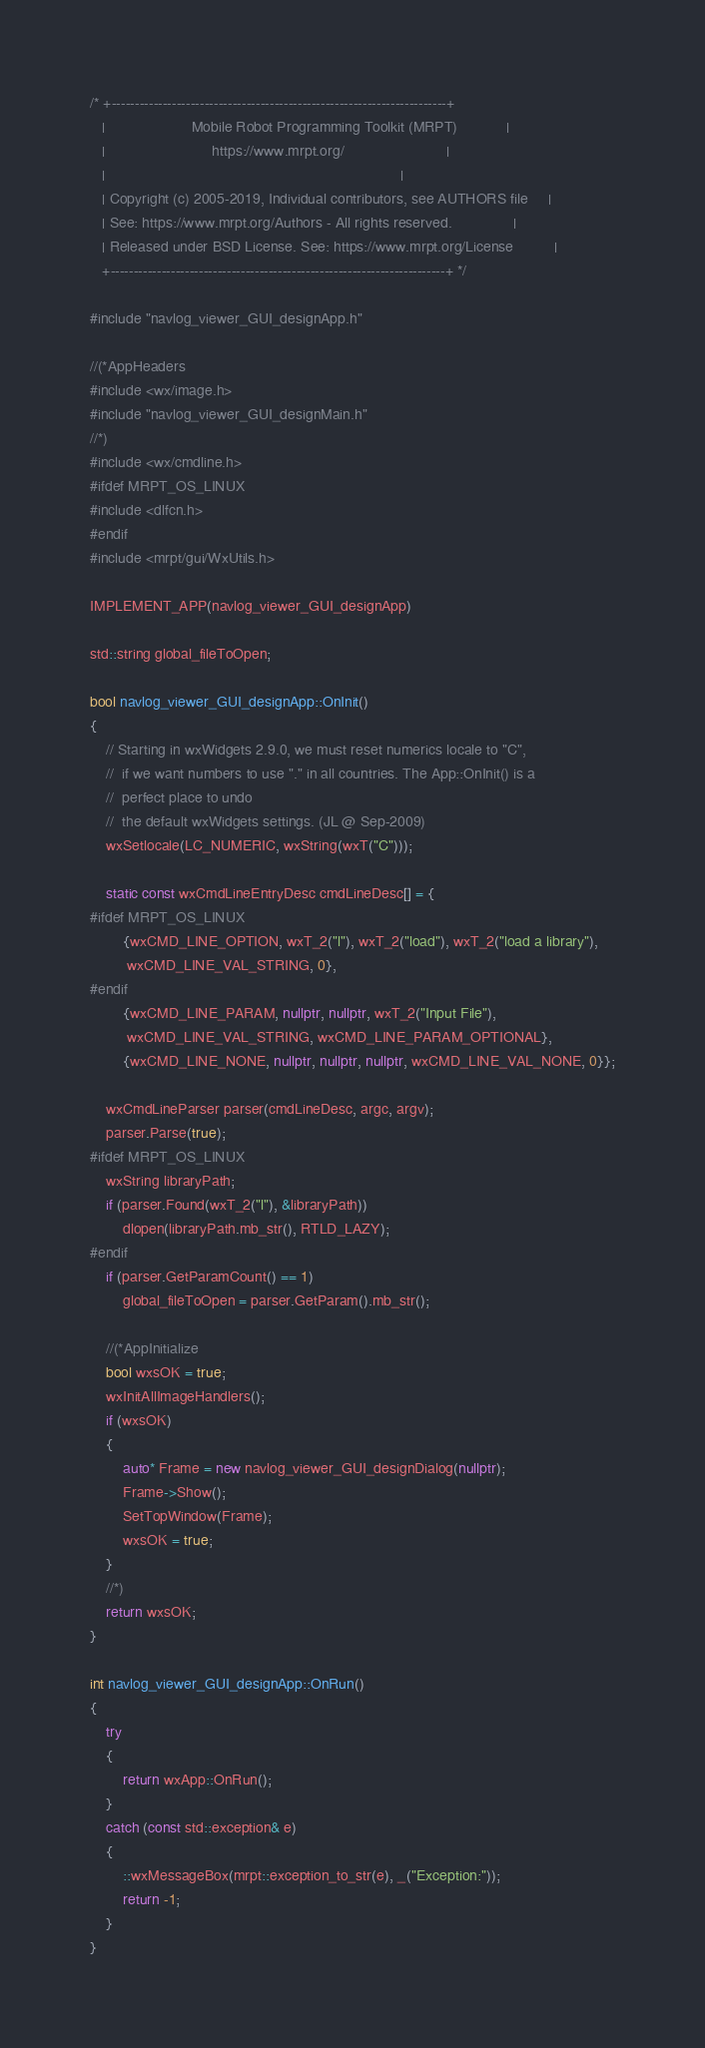<code> <loc_0><loc_0><loc_500><loc_500><_C++_>/* +------------------------------------------------------------------------+
   |                     Mobile Robot Programming Toolkit (MRPT)            |
   |                          https://www.mrpt.org/                         |
   |                                                                        |
   | Copyright (c) 2005-2019, Individual contributors, see AUTHORS file     |
   | See: https://www.mrpt.org/Authors - All rights reserved.               |
   | Released under BSD License. See: https://www.mrpt.org/License          |
   +------------------------------------------------------------------------+ */

#include "navlog_viewer_GUI_designApp.h"

//(*AppHeaders
#include <wx/image.h>
#include "navlog_viewer_GUI_designMain.h"
//*)
#include <wx/cmdline.h>
#ifdef MRPT_OS_LINUX
#include <dlfcn.h>
#endif
#include <mrpt/gui/WxUtils.h>

IMPLEMENT_APP(navlog_viewer_GUI_designApp)

std::string global_fileToOpen;

bool navlog_viewer_GUI_designApp::OnInit()
{
	// Starting in wxWidgets 2.9.0, we must reset numerics locale to "C",
	//  if we want numbers to use "." in all countries. The App::OnInit() is a
	//  perfect place to undo
	//  the default wxWidgets settings. (JL @ Sep-2009)
	wxSetlocale(LC_NUMERIC, wxString(wxT("C")));

	static const wxCmdLineEntryDesc cmdLineDesc[] = {
#ifdef MRPT_OS_LINUX
		{wxCMD_LINE_OPTION, wxT_2("l"), wxT_2("load"), wxT_2("load a library"),
		 wxCMD_LINE_VAL_STRING, 0},
#endif
		{wxCMD_LINE_PARAM, nullptr, nullptr, wxT_2("Input File"),
		 wxCMD_LINE_VAL_STRING, wxCMD_LINE_PARAM_OPTIONAL},
		{wxCMD_LINE_NONE, nullptr, nullptr, nullptr, wxCMD_LINE_VAL_NONE, 0}};

	wxCmdLineParser parser(cmdLineDesc, argc, argv);
	parser.Parse(true);
#ifdef MRPT_OS_LINUX
	wxString libraryPath;
	if (parser.Found(wxT_2("l"), &libraryPath))
		dlopen(libraryPath.mb_str(), RTLD_LAZY);
#endif
	if (parser.GetParamCount() == 1)
		global_fileToOpen = parser.GetParam().mb_str();

	//(*AppInitialize
	bool wxsOK = true;
	wxInitAllImageHandlers();
	if (wxsOK)
	{
		auto* Frame = new navlog_viewer_GUI_designDialog(nullptr);
		Frame->Show();
		SetTopWindow(Frame);
		wxsOK = true;
	}
	//*)
	return wxsOK;
}

int navlog_viewer_GUI_designApp::OnRun()
{
	try
	{
		return wxApp::OnRun();
	}
	catch (const std::exception& e)
	{
		::wxMessageBox(mrpt::exception_to_str(e), _("Exception:"));
		return -1;
	}
}
</code> 